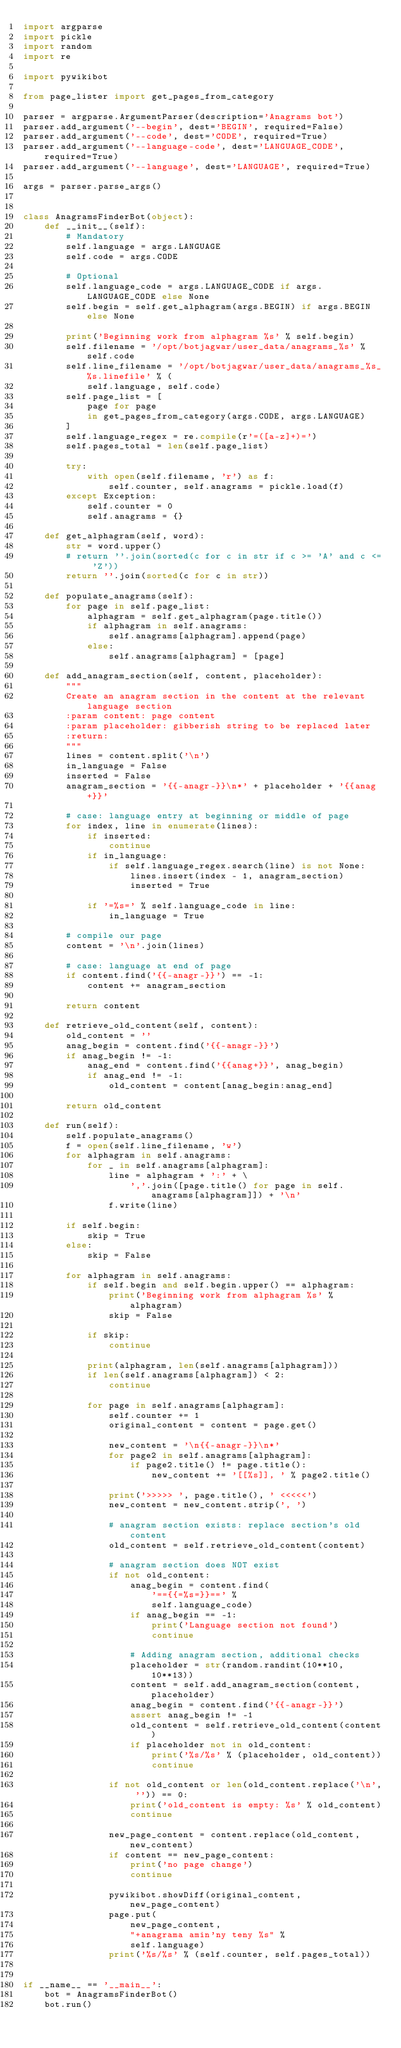<code> <loc_0><loc_0><loc_500><loc_500><_Python_>import argparse
import pickle
import random
import re

import pywikibot

from page_lister import get_pages_from_category

parser = argparse.ArgumentParser(description='Anagrams bot')
parser.add_argument('--begin', dest='BEGIN', required=False)
parser.add_argument('--code', dest='CODE', required=True)
parser.add_argument('--language-code', dest='LANGUAGE_CODE', required=True)
parser.add_argument('--language', dest='LANGUAGE', required=True)

args = parser.parse_args()


class AnagramsFinderBot(object):
    def __init__(self):
        # Mandatory
        self.language = args.LANGUAGE
        self.code = args.CODE

        # Optional
        self.language_code = args.LANGUAGE_CODE if args.LANGUAGE_CODE else None
        self.begin = self.get_alphagram(args.BEGIN) if args.BEGIN else None

        print('Beginning work from alphagram %s' % self.begin)
        self.filename = '/opt/botjagwar/user_data/anagrams_%s' % self.code
        self.line_filename = '/opt/botjagwar/user_data/anagrams_%s_%s.linefile' % (
            self.language, self.code)
        self.page_list = [
            page for page
            in get_pages_from_category(args.CODE, args.LANGUAGE)
        ]
        self.language_regex = re.compile(r'=([a-z]+)=')
        self.pages_total = len(self.page_list)

        try:
            with open(self.filename, 'r') as f:
                self.counter, self.anagrams = pickle.load(f)
        except Exception:
            self.counter = 0
            self.anagrams = {}

    def get_alphagram(self, word):
        str = word.upper()
        # return ''.join(sorted(c for c in str if c >= 'A' and c <= 'Z'))
        return ''.join(sorted(c for c in str))

    def populate_anagrams(self):
        for page in self.page_list:
            alphagram = self.get_alphagram(page.title())
            if alphagram in self.anagrams:
                self.anagrams[alphagram].append(page)
            else:
                self.anagrams[alphagram] = [page]

    def add_anagram_section(self, content, placeholder):
        """
        Create an anagram section in the content at the relevant language section
        :param content: page content
        :param placeholder: gibberish string to be replaced later
        :return:
        """
        lines = content.split('\n')
        in_language = False
        inserted = False
        anagram_section = '{{-anagr-}}\n*' + placeholder + '{{anag+}}'

        # case: language entry at beginning or middle of page
        for index, line in enumerate(lines):
            if inserted:
                continue
            if in_language:
                if self.language_regex.search(line) is not None:
                    lines.insert(index - 1, anagram_section)
                    inserted = True

            if '=%s=' % self.language_code in line:
                in_language = True

        # compile our page
        content = '\n'.join(lines)

        # case: language at end of page
        if content.find('{{-anagr-}}') == -1:
            content += anagram_section

        return content

    def retrieve_old_content(self, content):
        old_content = ''
        anag_begin = content.find('{{-anagr-}}')
        if anag_begin != -1:
            anag_end = content.find('{{anag+}}', anag_begin)
            if anag_end != -1:
                old_content = content[anag_begin:anag_end]

        return old_content

    def run(self):
        self.populate_anagrams()
        f = open(self.line_filename, 'w')
        for alphagram in self.anagrams:
            for _ in self.anagrams[alphagram]:
                line = alphagram + ':' + \
                    ','.join([page.title() for page in self.anagrams[alphagram]]) + '\n'
                f.write(line)

        if self.begin:
            skip = True
        else:
            skip = False

        for alphagram in self.anagrams:
            if self.begin and self.begin.upper() == alphagram:
                print('Beginning work from alphagram %s' % alphagram)
                skip = False

            if skip:
                continue

            print(alphagram, len(self.anagrams[alphagram]))
            if len(self.anagrams[alphagram]) < 2:
                continue

            for page in self.anagrams[alphagram]:
                self.counter += 1
                original_content = content = page.get()

                new_content = '\n{{-anagr-}}\n*'
                for page2 in self.anagrams[alphagram]:
                    if page2.title() != page.title():
                        new_content += '[[%s]], ' % page2.title()

                print('>>>>> ', page.title(), ' <<<<<')
                new_content = new_content.strip(', ')

                # anagram section exists: replace section's old content
                old_content = self.retrieve_old_content(content)

                # anagram section does NOT exist
                if not old_content:
                    anag_begin = content.find(
                        '=={{=%s=}}==' %
                        self.language_code)
                    if anag_begin == -1:
                        print('Language section not found')
                        continue

                    # Adding anagram section, additional checks
                    placeholder = str(random.randint(10**10, 10**13))
                    content = self.add_anagram_section(content, placeholder)
                    anag_begin = content.find('{{-anagr-}}')
                    assert anag_begin != -1
                    old_content = self.retrieve_old_content(content)
                    if placeholder not in old_content:
                        print('%s/%s' % (placeholder, old_content))
                        continue

                if not old_content or len(old_content.replace('\n', '')) == 0:
                    print('old_content is empty: %s' % old_content)
                    continue

                new_page_content = content.replace(old_content, new_content)
                if content == new_page_content:
                    print('no page change')
                    continue

                pywikibot.showDiff(original_content, new_page_content)
                page.put(
                    new_page_content,
                    "+anagrama amin'ny teny %s" %
                    self.language)
                print('%s/%s' % (self.counter, self.pages_total))


if __name__ == '__main__':
    bot = AnagramsFinderBot()
    bot.run()
</code> 